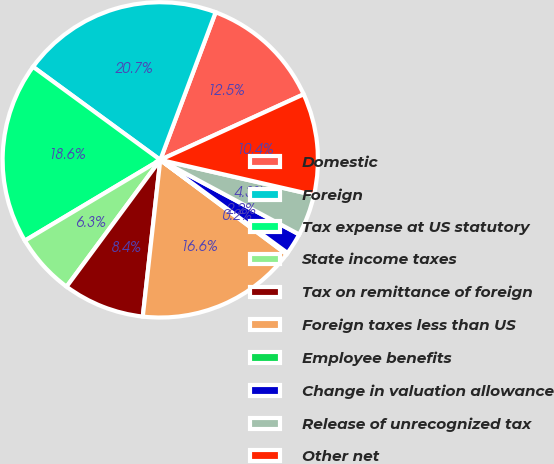Convert chart. <chart><loc_0><loc_0><loc_500><loc_500><pie_chart><fcel>Domestic<fcel>Foreign<fcel>Tax expense at US statutory<fcel>State income taxes<fcel>Tax on remittance of foreign<fcel>Foreign taxes less than US<fcel>Employee benefits<fcel>Change in valuation allowance<fcel>Release of unrecognized tax<fcel>Other net<nl><fcel>12.46%<fcel>20.66%<fcel>18.61%<fcel>6.31%<fcel>8.36%<fcel>16.56%<fcel>0.16%<fcel>2.21%<fcel>4.26%<fcel>10.41%<nl></chart> 